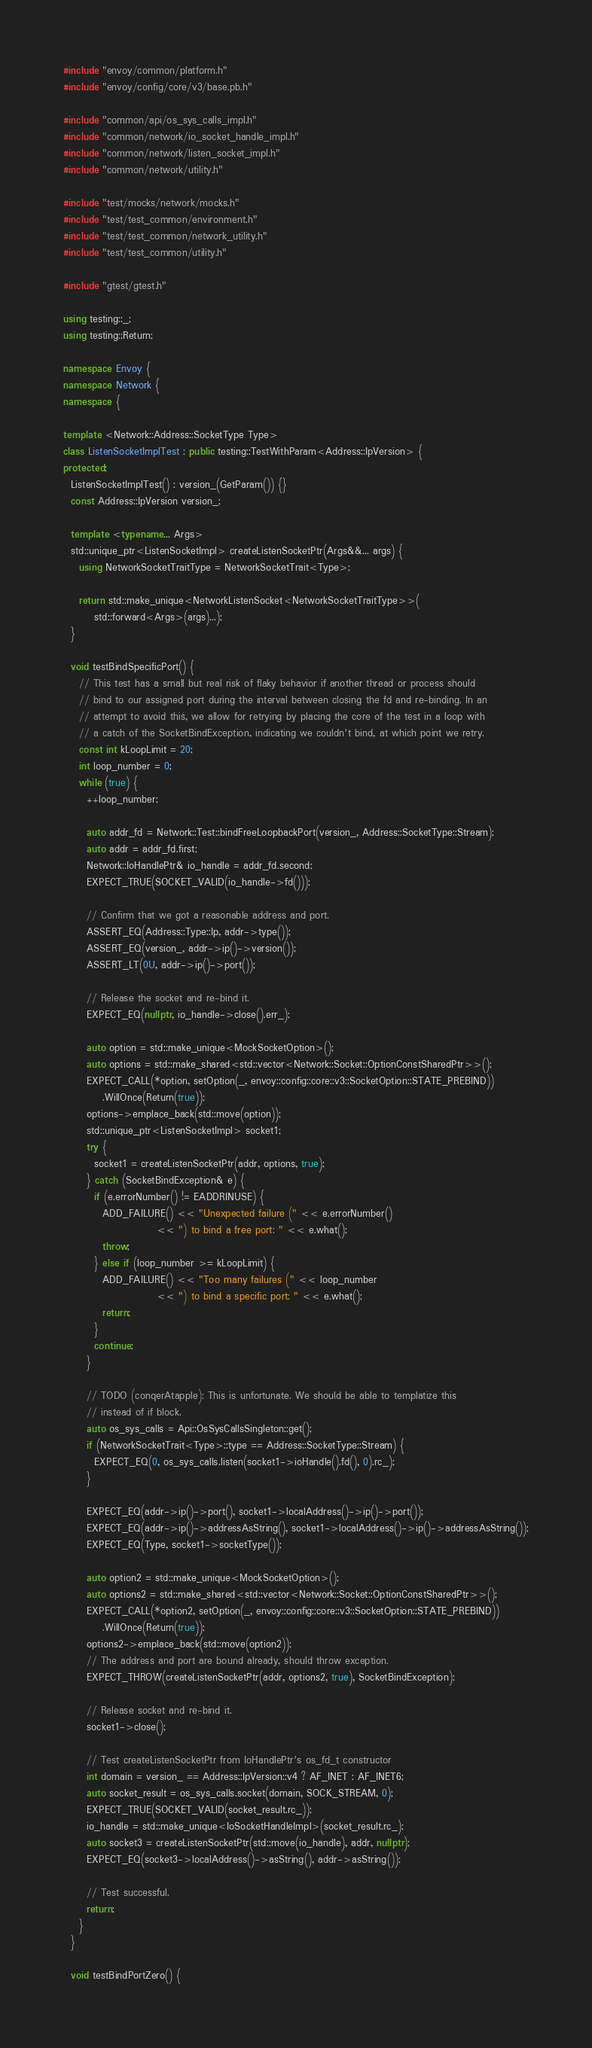Convert code to text. <code><loc_0><loc_0><loc_500><loc_500><_C++_>#include "envoy/common/platform.h"
#include "envoy/config/core/v3/base.pb.h"

#include "common/api/os_sys_calls_impl.h"
#include "common/network/io_socket_handle_impl.h"
#include "common/network/listen_socket_impl.h"
#include "common/network/utility.h"

#include "test/mocks/network/mocks.h"
#include "test/test_common/environment.h"
#include "test/test_common/network_utility.h"
#include "test/test_common/utility.h"

#include "gtest/gtest.h"

using testing::_;
using testing::Return;

namespace Envoy {
namespace Network {
namespace {

template <Network::Address::SocketType Type>
class ListenSocketImplTest : public testing::TestWithParam<Address::IpVersion> {
protected:
  ListenSocketImplTest() : version_(GetParam()) {}
  const Address::IpVersion version_;

  template <typename... Args>
  std::unique_ptr<ListenSocketImpl> createListenSocketPtr(Args&&... args) {
    using NetworkSocketTraitType = NetworkSocketTrait<Type>;

    return std::make_unique<NetworkListenSocket<NetworkSocketTraitType>>(
        std::forward<Args>(args)...);
  }

  void testBindSpecificPort() {
    // This test has a small but real risk of flaky behavior if another thread or process should
    // bind to our assigned port during the interval between closing the fd and re-binding. In an
    // attempt to avoid this, we allow for retrying by placing the core of the test in a loop with
    // a catch of the SocketBindException, indicating we couldn't bind, at which point we retry.
    const int kLoopLimit = 20;
    int loop_number = 0;
    while (true) {
      ++loop_number;

      auto addr_fd = Network::Test::bindFreeLoopbackPort(version_, Address::SocketType::Stream);
      auto addr = addr_fd.first;
      Network::IoHandlePtr& io_handle = addr_fd.second;
      EXPECT_TRUE(SOCKET_VALID(io_handle->fd()));

      // Confirm that we got a reasonable address and port.
      ASSERT_EQ(Address::Type::Ip, addr->type());
      ASSERT_EQ(version_, addr->ip()->version());
      ASSERT_LT(0U, addr->ip()->port());

      // Release the socket and re-bind it.
      EXPECT_EQ(nullptr, io_handle->close().err_);

      auto option = std::make_unique<MockSocketOption>();
      auto options = std::make_shared<std::vector<Network::Socket::OptionConstSharedPtr>>();
      EXPECT_CALL(*option, setOption(_, envoy::config::core::v3::SocketOption::STATE_PREBIND))
          .WillOnce(Return(true));
      options->emplace_back(std::move(option));
      std::unique_ptr<ListenSocketImpl> socket1;
      try {
        socket1 = createListenSocketPtr(addr, options, true);
      } catch (SocketBindException& e) {
        if (e.errorNumber() != EADDRINUSE) {
          ADD_FAILURE() << "Unexpected failure (" << e.errorNumber()
                        << ") to bind a free port: " << e.what();
          throw;
        } else if (loop_number >= kLoopLimit) {
          ADD_FAILURE() << "Too many failures (" << loop_number
                        << ") to bind a specific port: " << e.what();
          return;
        }
        continue;
      }

      // TODO (conqerAtapple): This is unfortunate. We should be able to templatize this
      // instead of if block.
      auto os_sys_calls = Api::OsSysCallsSingleton::get();
      if (NetworkSocketTrait<Type>::type == Address::SocketType::Stream) {
        EXPECT_EQ(0, os_sys_calls.listen(socket1->ioHandle().fd(), 0).rc_);
      }

      EXPECT_EQ(addr->ip()->port(), socket1->localAddress()->ip()->port());
      EXPECT_EQ(addr->ip()->addressAsString(), socket1->localAddress()->ip()->addressAsString());
      EXPECT_EQ(Type, socket1->socketType());

      auto option2 = std::make_unique<MockSocketOption>();
      auto options2 = std::make_shared<std::vector<Network::Socket::OptionConstSharedPtr>>();
      EXPECT_CALL(*option2, setOption(_, envoy::config::core::v3::SocketOption::STATE_PREBIND))
          .WillOnce(Return(true));
      options2->emplace_back(std::move(option2));
      // The address and port are bound already, should throw exception.
      EXPECT_THROW(createListenSocketPtr(addr, options2, true), SocketBindException);

      // Release socket and re-bind it.
      socket1->close();

      // Test createListenSocketPtr from IoHandlePtr's os_fd_t constructor
      int domain = version_ == Address::IpVersion::v4 ? AF_INET : AF_INET6;
      auto socket_result = os_sys_calls.socket(domain, SOCK_STREAM, 0);
      EXPECT_TRUE(SOCKET_VALID(socket_result.rc_));
      io_handle = std::make_unique<IoSocketHandleImpl>(socket_result.rc_);
      auto socket3 = createListenSocketPtr(std::move(io_handle), addr, nullptr);
      EXPECT_EQ(socket3->localAddress()->asString(), addr->asString());

      // Test successful.
      return;
    }
  }

  void testBindPortZero() {</code> 